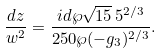Convert formula to latex. <formula><loc_0><loc_0><loc_500><loc_500>\frac { d z } { w ^ { 2 } } = \frac { i { d \wp } \sqrt { 1 5 } \, { 5 } ^ { 2 / 3 } } { 2 5 0 \wp ( - g _ { 3 } ) ^ { 2 / 3 } } .</formula> 